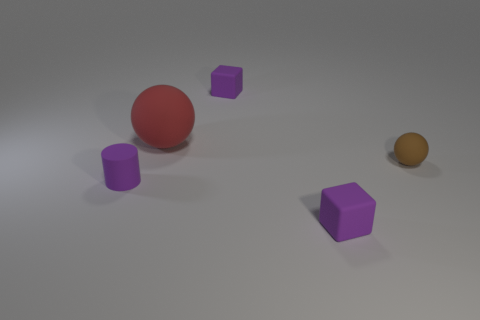Add 4 small matte cylinders. How many objects exist? 9 Subtract 2 cubes. How many cubes are left? 0 Subtract all yellow spheres. Subtract all brown cylinders. How many spheres are left? 2 Subtract all green cylinders. How many red spheres are left? 1 Subtract all big blue matte cylinders. Subtract all purple matte cylinders. How many objects are left? 4 Add 5 rubber blocks. How many rubber blocks are left? 7 Add 5 tiny objects. How many tiny objects exist? 9 Subtract 0 red cylinders. How many objects are left? 5 Subtract all balls. How many objects are left? 3 